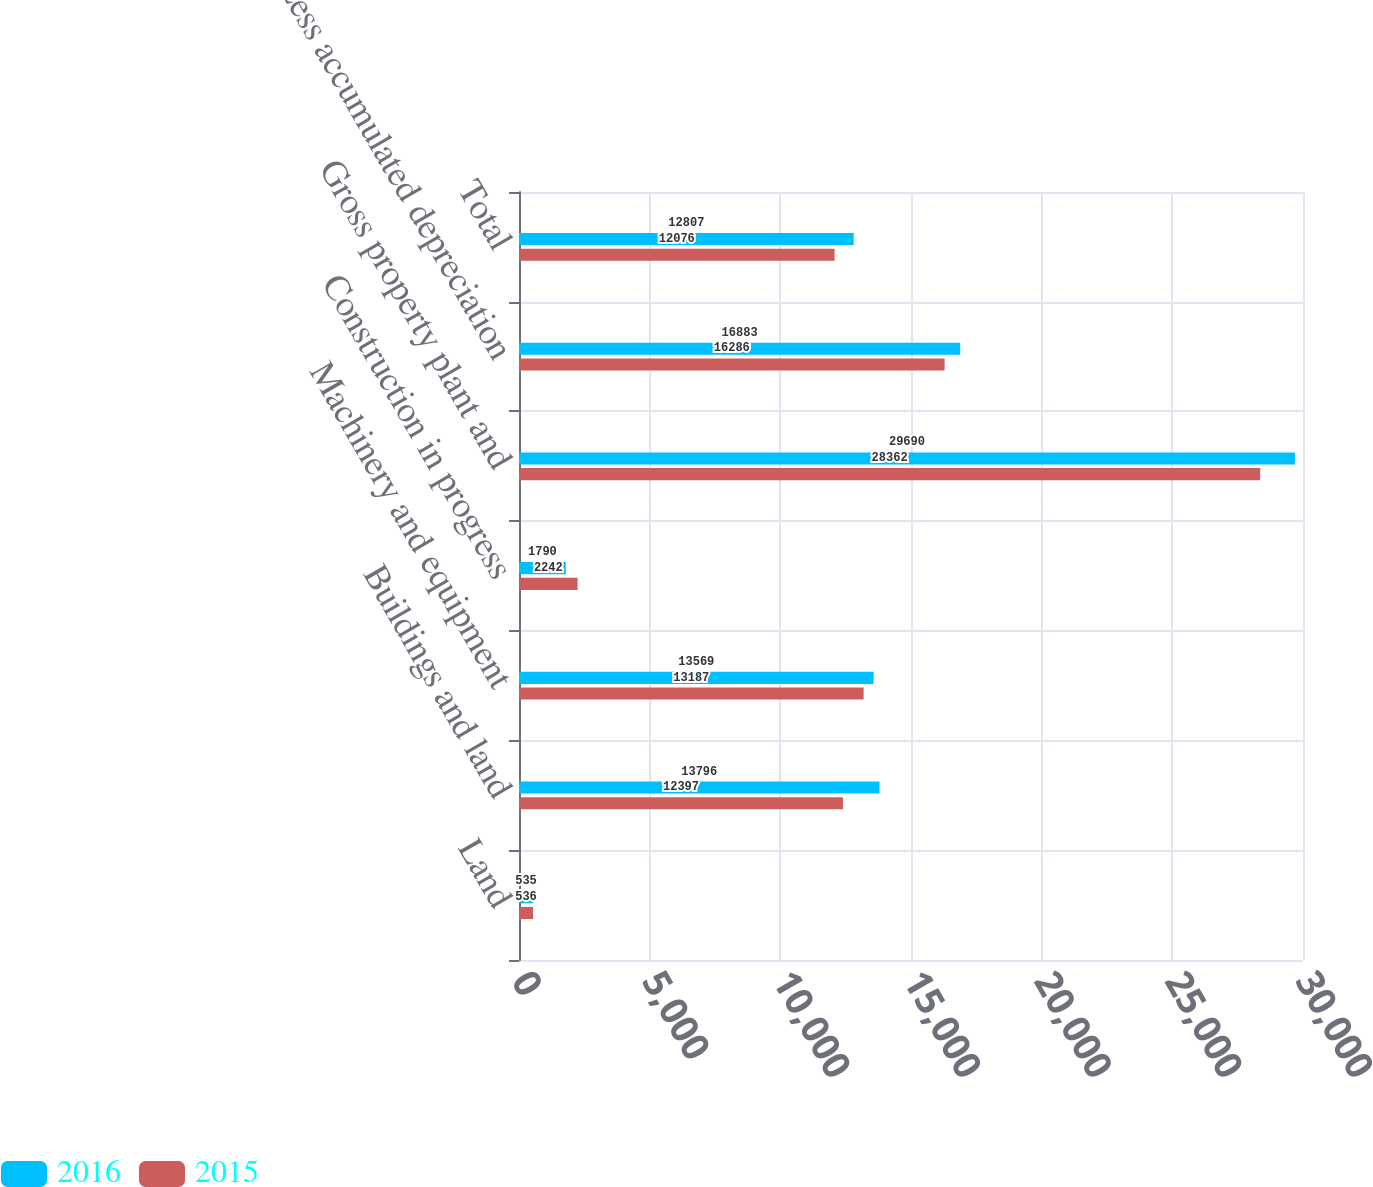Convert chart. <chart><loc_0><loc_0><loc_500><loc_500><stacked_bar_chart><ecel><fcel>Land<fcel>Buildings and land<fcel>Machinery and equipment<fcel>Construction in progress<fcel>Gross property plant and<fcel>Less accumulated depreciation<fcel>Total<nl><fcel>2016<fcel>535<fcel>13796<fcel>13569<fcel>1790<fcel>29690<fcel>16883<fcel>12807<nl><fcel>2015<fcel>536<fcel>12397<fcel>13187<fcel>2242<fcel>28362<fcel>16286<fcel>12076<nl></chart> 